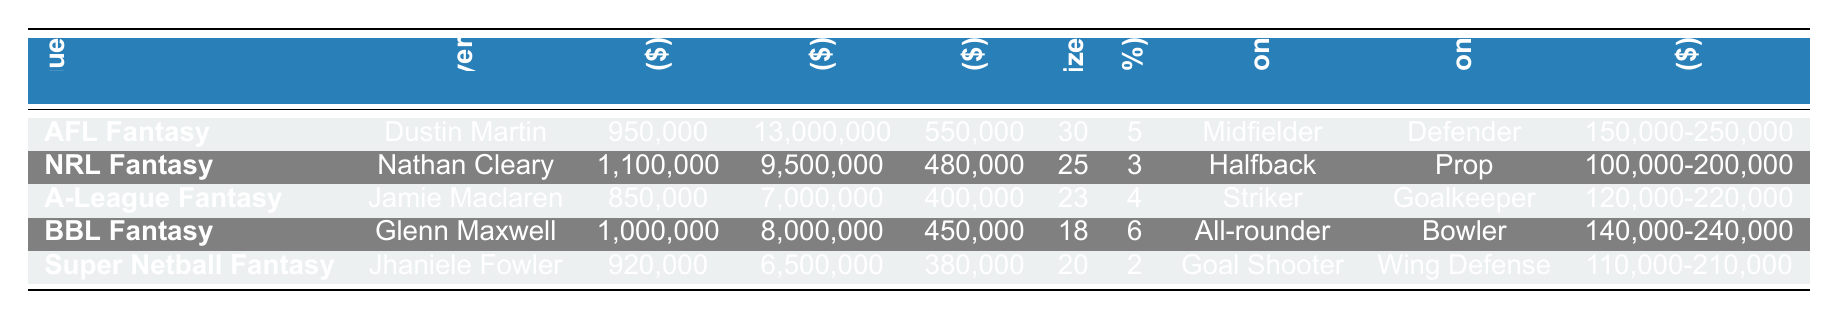What is the player cost for Dustin Martin in AFL Fantasy? The table lists the player cost for each top player. For Dustin Martin, the player cost is $950,000.
Answer: $950,000 Which fantasy league has the lowest team budget? By comparing the team budgets for each league, the lowest is $6,500,000 for Super Netball Fantasy.
Answer: $6,500,000 What is the average player cost in NRL Fantasy? The average player cost for NRL Fantasy is stated in the table as $480,000.
Answer: $480,000 Which position is the most expensive in A-League Fantasy? According to the table, the most expensive position in A-League Fantasy is Striker.
Answer: Striker What is the total team budget for AFL Fantasy and BBL Fantasy combined? The total is calculated by adding the team budgets: $13,000,000 (AFL Fantasy) + $8,000,000 (BBL Fantasy) = $21,000,000.
Answer: $21,000,000 Is the rookie price range for NRL Fantasy greater than $200,000? The rookie price range for NRL Fantasy is $100,000-$200,000, which does not exceed $200,000. Thus, the answer is no.
Answer: No What is the difference between the player cost of Nathan Cleary and Jamie Maclaren? Nathan Cleary costs $1,100,000 and Jamie Maclaren costs $850,000. The difference is $1,100,000 - $850,000 = $250,000.
Answer: $250,000 Which fantasy league has the highest average player cost? By comparing the average player costs, AFL Fantasy has the highest at $550,000.
Answer: AFL Fantasy If Super Netball Fantasy increased its salary cap by 10%, what would its new salary cap percentage be? The salary cap increase for Super Netball Fantasy is 2%. Adding 10% means the new total would be 2% + 10% = 12%.
Answer: 12% What is the cheapest position in BBL Fantasy? According to the data, the cheapest position in BBL Fantasy is Bowler.
Answer: Bowler 